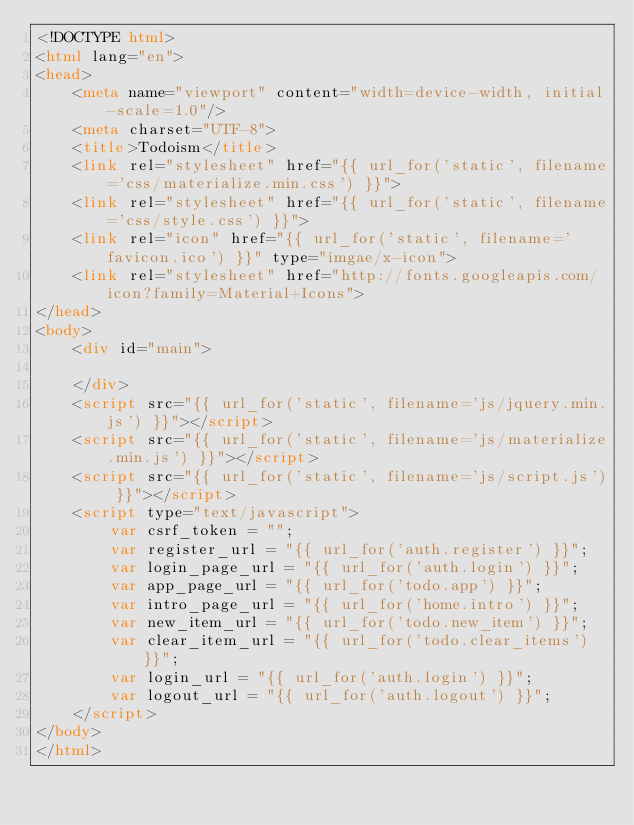Convert code to text. <code><loc_0><loc_0><loc_500><loc_500><_HTML_><!DOCTYPE html>
<html lang="en">
<head>
    <meta name="viewport" content="width=device-width, initial-scale=1.0"/>
    <meta charset="UTF-8">
    <title>Todoism</title>
    <link rel="stylesheet" href="{{ url_for('static', filename='css/materialize.min.css') }}">
    <link rel="stylesheet" href="{{ url_for('static', filename='css/style.css') }}">
    <link rel="icon" href="{{ url_for('static', filename='favicon.ico') }}" type="imgae/x-icon">
    <link rel="stylesheet" href="http://fonts.googleapis.com/icon?family=Material+Icons">
</head>
<body>
    <div id="main">

    </div>
    <script src="{{ url_for('static', filename='js/jquery.min.js') }}"></script>
    <script src="{{ url_for('static', filename='js/materialize.min.js') }}"></script>
    <script src="{{ url_for('static', filename='js/script.js') }}"></script>
    <script type="text/javascript">
        var csrf_token = "";
        var register_url = "{{ url_for('auth.register') }}";
        var login_page_url = "{{ url_for('auth.login') }}";
        var app_page_url = "{{ url_for('todo.app') }}";
        var intro_page_url = "{{ url_for('home.intro') }}";
        var new_item_url = "{{ url_for('todo.new_item') }}";
        var clear_item_url = "{{ url_for('todo.clear_items') }}";
        var login_url = "{{ url_for('auth.login') }}";
        var logout_url = "{{ url_for('auth.logout') }}";
    </script>
</body>
</html></code> 